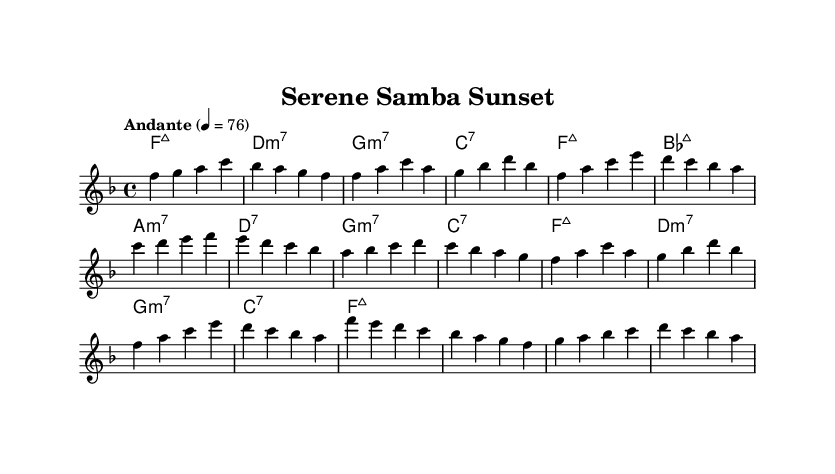What is the key signature of this music? The music has a key signature of F major, which includes one flat (B flat). This is determined by the key signature at the beginning of the sheet music, which signifies the key of the piece.
Answer: F major What is the time signature of this piece? The time signature is 4/4, indicated at the beginning of the score. This means there are four beats in each measure and the quarter note gets one beat.
Answer: 4/4 What is the tempo marking of the music? The tempo is indicated as "Andante" with a metronome marking of 76. This signifies a moderately slow pace. This information is found near the beginning of the score, typically associated with how fast the piece should be played.
Answer: Andante, 76 How many sections are in the piece? The piece has three main sections labeled A, B, and C, with A also being repeated. The structure is indicated in the melody section of the score where the sections are marked.
Answer: Three What is the first chord of the piece? The first chord of the piece is F major 7, as indicated in the harmonies section at the start. This is the initial harmony laid out before the melody begins.
Answer: F major 7 What type of music is being performed? The piece is labeled as a bossa nova, a genre of Brazilian music characterized by its syncopated rhythms and relaxed feel. This can be inferred from the title of the piece, "Serene Samba Sunset," and the overall style.
Answer: Bossa nova 